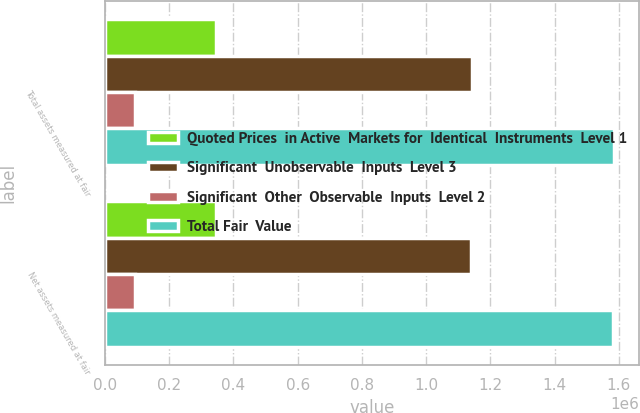Convert chart. <chart><loc_0><loc_0><loc_500><loc_500><stacked_bar_chart><ecel><fcel>Total assets measured at fair<fcel>Net assets measured at fair<nl><fcel>Quoted Prices  in Active  Markets for  Identical  Instruments  Level 1<fcel>346722<fcel>346722<nl><fcel>Significant  Unobservable  Inputs  Level 3<fcel>1.14216e+06<fcel>1.14108e+06<nl><fcel>Significant  Other  Observable  Inputs  Level 2<fcel>94846<fcel>92736<nl><fcel>Total Fair  Value<fcel>1.58373e+06<fcel>1.58054e+06<nl></chart> 